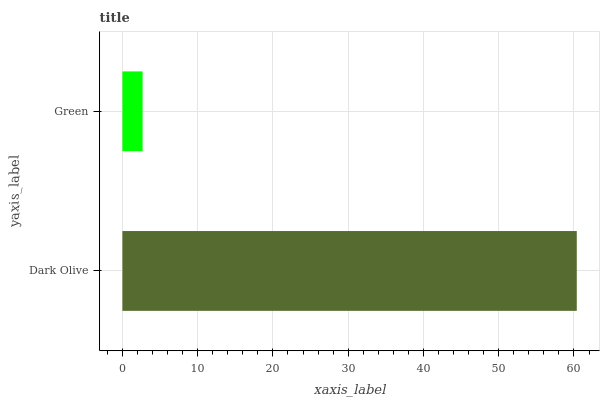Is Green the minimum?
Answer yes or no. Yes. Is Dark Olive the maximum?
Answer yes or no. Yes. Is Green the maximum?
Answer yes or no. No. Is Dark Olive greater than Green?
Answer yes or no. Yes. Is Green less than Dark Olive?
Answer yes or no. Yes. Is Green greater than Dark Olive?
Answer yes or no. No. Is Dark Olive less than Green?
Answer yes or no. No. Is Dark Olive the high median?
Answer yes or no. Yes. Is Green the low median?
Answer yes or no. Yes. Is Green the high median?
Answer yes or no. No. Is Dark Olive the low median?
Answer yes or no. No. 